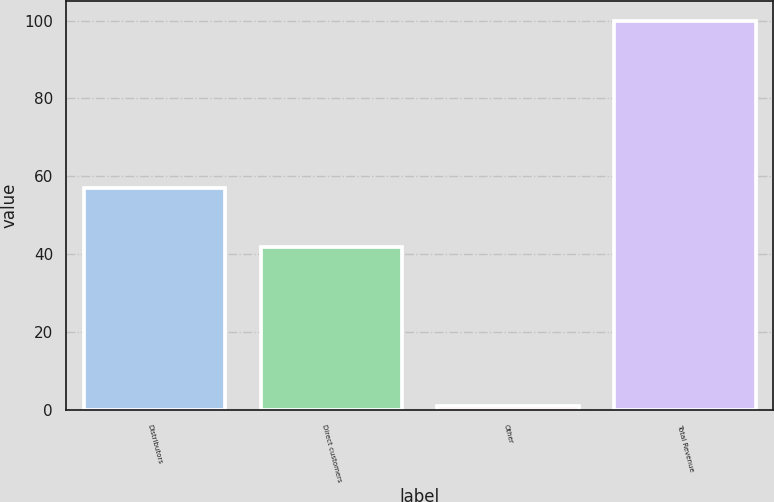Convert chart to OTSL. <chart><loc_0><loc_0><loc_500><loc_500><bar_chart><fcel>Distributors<fcel>Direct customers<fcel>Other<fcel>Total Revenue<nl><fcel>57<fcel>42<fcel>1<fcel>100<nl></chart> 